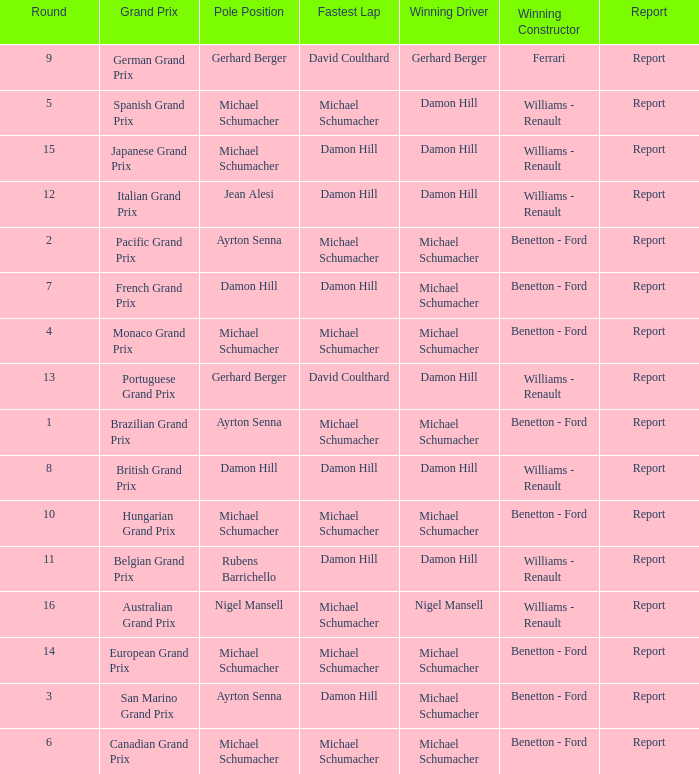Name the lowest round for when pole position and winning driver is michael schumacher 4.0. 